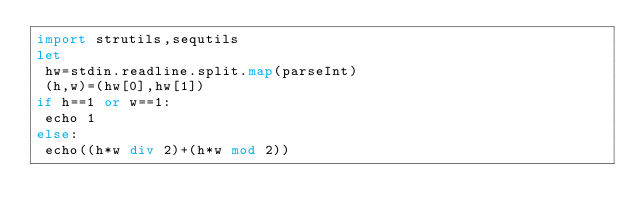<code> <loc_0><loc_0><loc_500><loc_500><_Nim_>import strutils,sequtils
let
 hw=stdin.readline.split.map(parseInt)
 (h,w)=(hw[0],hw[1])
if h==1 or w==1:
 echo 1
else:
 echo((h*w div 2)+(h*w mod 2))</code> 